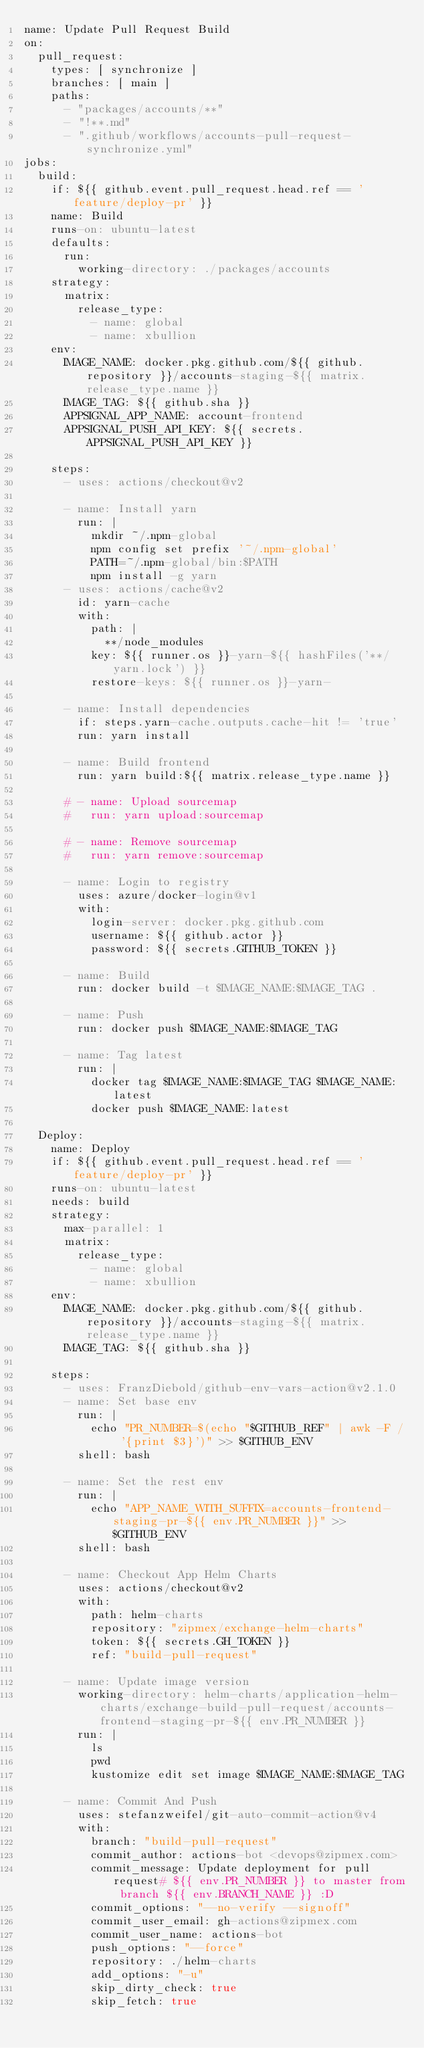<code> <loc_0><loc_0><loc_500><loc_500><_YAML_>name: Update Pull Request Build
on:
  pull_request:
    types: [ synchronize ]
    branches: [ main ]
    paths:
      - "packages/accounts/**"
      - "!**.md"
      - ".github/workflows/accounts-pull-request-synchronize.yml"
jobs:
  build:
    if: ${{ github.event.pull_request.head.ref == 'feature/deploy-pr' }}
    name: Build
    runs-on: ubuntu-latest
    defaults:
      run:
        working-directory: ./packages/accounts
    strategy:
      matrix:
        release_type:
          - name: global
          - name: xbullion
    env:
      IMAGE_NAME: docker.pkg.github.com/${{ github.repository }}/accounts-staging-${{ matrix.release_type.name }}
      IMAGE_TAG: ${{ github.sha }}
      APPSIGNAL_APP_NAME: account-frontend
      APPSIGNAL_PUSH_API_KEY: ${{ secrets.APPSIGNAL_PUSH_API_KEY }}

    steps:
      - uses: actions/checkout@v2

      - name: Install yarn
        run: |
          mkdir ~/.npm-global
          npm config set prefix '~/.npm-global'
          PATH=~/.npm-global/bin:$PATH
          npm install -g yarn
      - uses: actions/cache@v2
        id: yarn-cache
        with:
          path: |
            **/node_modules
          key: ${{ runner.os }}-yarn-${{ hashFiles('**/yarn.lock') }}
          restore-keys: ${{ runner.os }}-yarn-

      - name: Install dependencies
        if: steps.yarn-cache.outputs.cache-hit != 'true'
        run: yarn install

      - name: Build frontend
        run: yarn build:${{ matrix.release_type.name }}

      # - name: Upload sourcemap
      #   run: yarn upload:sourcemap

      # - name: Remove sourcemap
      #   run: yarn remove:sourcemap

      - name: Login to registry
        uses: azure/docker-login@v1
        with:
          login-server: docker.pkg.github.com
          username: ${{ github.actor }}
          password: ${{ secrets.GITHUB_TOKEN }}

      - name: Build
        run: docker build -t $IMAGE_NAME:$IMAGE_TAG .

      - name: Push
        run: docker push $IMAGE_NAME:$IMAGE_TAG

      - name: Tag latest
        run: |
          docker tag $IMAGE_NAME:$IMAGE_TAG $IMAGE_NAME:latest
          docker push $IMAGE_NAME:latest

  Deploy:
    name: Deploy
    if: ${{ github.event.pull_request.head.ref == 'feature/deploy-pr' }}
    runs-on: ubuntu-latest
    needs: build
    strategy:
      max-parallel: 1
      matrix:
        release_type:
          - name: global
          - name: xbullion
    env:
      IMAGE_NAME: docker.pkg.github.com/${{ github.repository }}/accounts-staging-${{ matrix.release_type.name }}
      IMAGE_TAG: ${{ github.sha }}

    steps:
      - uses: FranzDiebold/github-env-vars-action@v2.1.0
      - name: Set base env
        run: |
          echo "PR_NUMBER=$(echo "$GITHUB_REF" | awk -F / '{print $3}')" >> $GITHUB_ENV
        shell: bash

      - name: Set the rest env
        run: |
          echo "APP_NAME_WITH_SUFFIX=accounts-frontend-staging-pr-${{ env.PR_NUMBER }}" >> $GITHUB_ENV
        shell: bash

      - name: Checkout App Helm Charts
        uses: actions/checkout@v2
        with:
          path: helm-charts
          repository: "zipmex/exchange-helm-charts"
          token: ${{ secrets.GH_TOKEN }}
          ref: "build-pull-request"

      - name: Update image version
        working-directory: helm-charts/application-helm-charts/exchange-build-pull-request/accounts-frontend-staging-pr-${{ env.PR_NUMBER }}
        run: |
          ls
          pwd
          kustomize edit set image $IMAGE_NAME:$IMAGE_TAG

      - name: Commit And Push
        uses: stefanzweifel/git-auto-commit-action@v4
        with:
          branch: "build-pull-request"
          commit_author: actions-bot <devops@zipmex.com>
          commit_message: Update deployment for pull request# ${{ env.PR_NUMBER }} to master from branch ${{ env.BRANCH_NAME }} :D
          commit_options: "--no-verify --signoff"
          commit_user_email: gh-actions@zipmex.com
          commit_user_name: actions-bot
          push_options: "--force"
          repository: ./helm-charts
          add_options: "-u"
          skip_dirty_check: true
          skip_fetch: true


</code> 